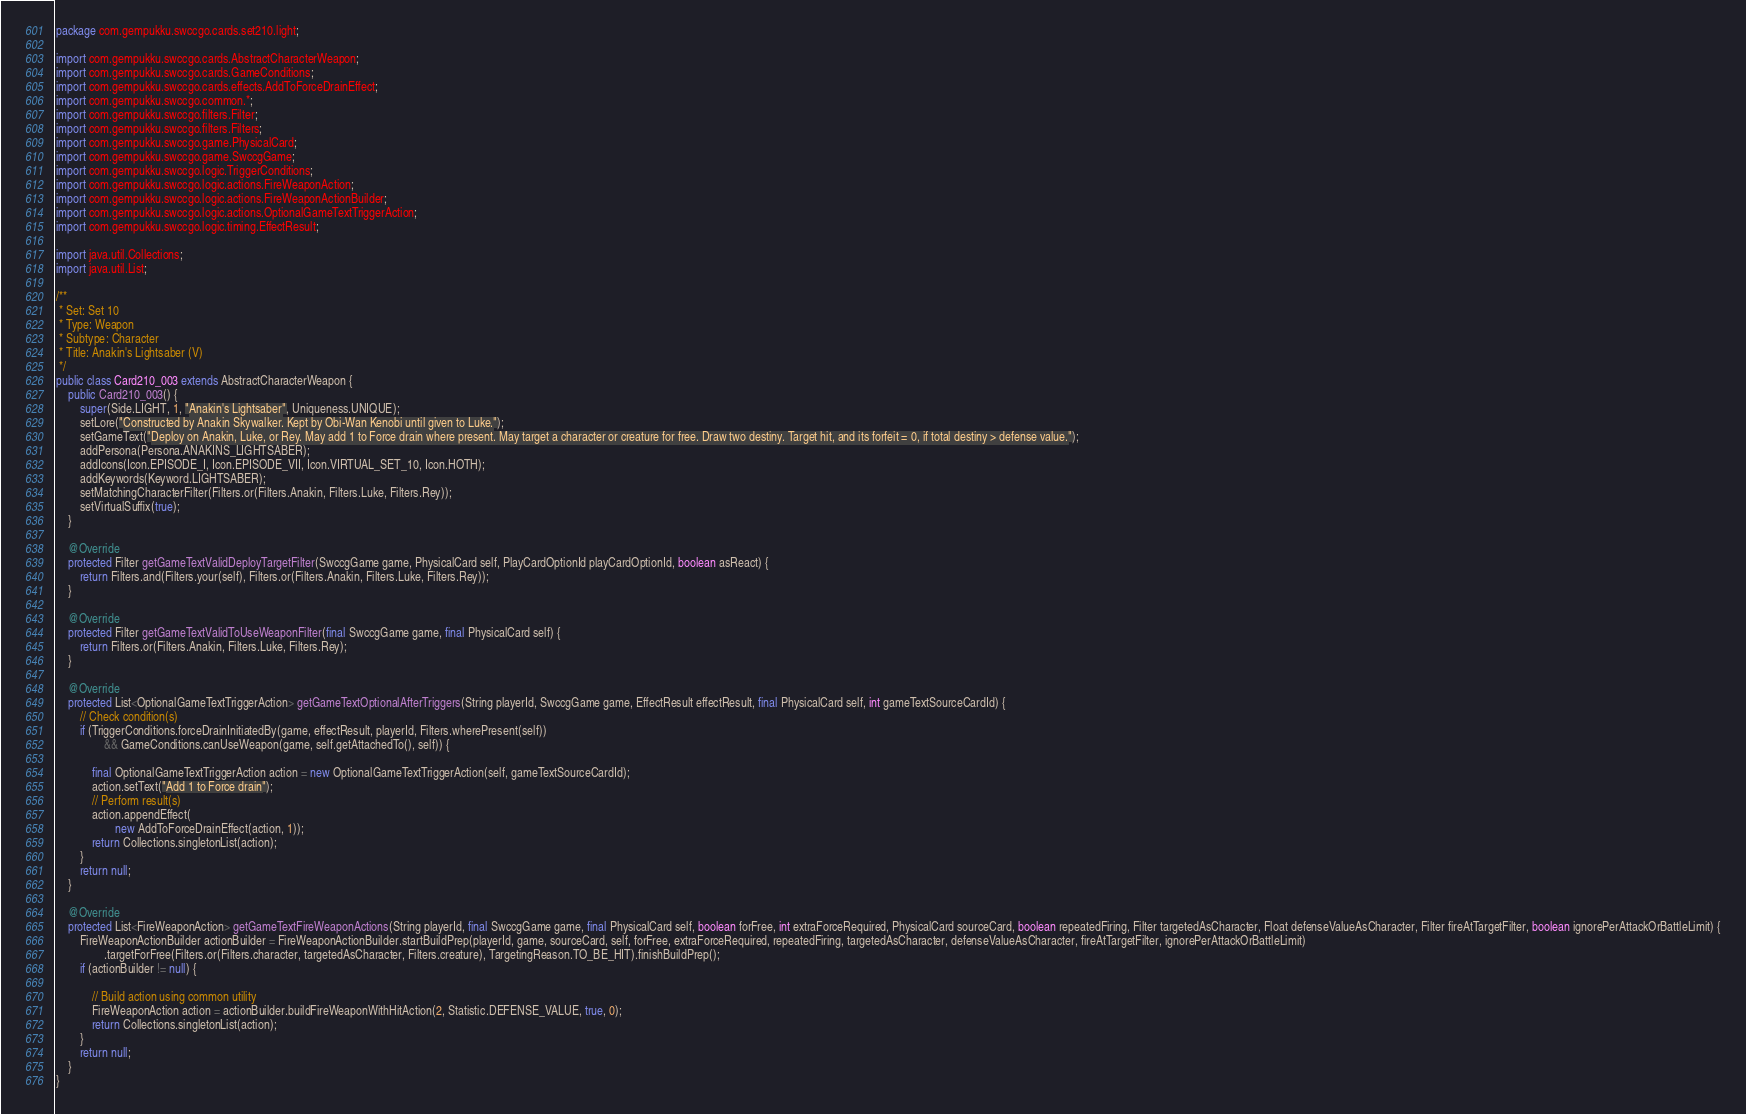Convert code to text. <code><loc_0><loc_0><loc_500><loc_500><_Java_>package com.gempukku.swccgo.cards.set210.light;

import com.gempukku.swccgo.cards.AbstractCharacterWeapon;
import com.gempukku.swccgo.cards.GameConditions;
import com.gempukku.swccgo.cards.effects.AddToForceDrainEffect;
import com.gempukku.swccgo.common.*;
import com.gempukku.swccgo.filters.Filter;
import com.gempukku.swccgo.filters.Filters;
import com.gempukku.swccgo.game.PhysicalCard;
import com.gempukku.swccgo.game.SwccgGame;
import com.gempukku.swccgo.logic.TriggerConditions;
import com.gempukku.swccgo.logic.actions.FireWeaponAction;
import com.gempukku.swccgo.logic.actions.FireWeaponActionBuilder;
import com.gempukku.swccgo.logic.actions.OptionalGameTextTriggerAction;
import com.gempukku.swccgo.logic.timing.EffectResult;

import java.util.Collections;
import java.util.List;

/**
 * Set: Set 10
 * Type: Weapon
 * Subtype: Character
 * Title: Anakin's Lightsaber (V)
 */
public class Card210_003 extends AbstractCharacterWeapon {
    public Card210_003() {
        super(Side.LIGHT, 1, "Anakin's Lightsaber", Uniqueness.UNIQUE);
        setLore("Constructed by Anakin Skywalker. Kept by Obi-Wan Kenobi until given to Luke.");
        setGameText("Deploy on Anakin, Luke, or Rey. May add 1 to Force drain where present. May target a character or creature for free. Draw two destiny. Target hit, and its forfeit = 0, if total destiny > defense value.");
        addPersona(Persona.ANAKINS_LIGHTSABER);
        addIcons(Icon.EPISODE_I, Icon.EPISODE_VII, Icon.VIRTUAL_SET_10, Icon.HOTH);
        addKeywords(Keyword.LIGHTSABER);
        setMatchingCharacterFilter(Filters.or(Filters.Anakin, Filters.Luke, Filters.Rey));
        setVirtualSuffix(true);
    }

    @Override
    protected Filter getGameTextValidDeployTargetFilter(SwccgGame game, PhysicalCard self, PlayCardOptionId playCardOptionId, boolean asReact) {
        return Filters.and(Filters.your(self), Filters.or(Filters.Anakin, Filters.Luke, Filters.Rey));
    }

    @Override
    protected Filter getGameTextValidToUseWeaponFilter(final SwccgGame game, final PhysicalCard self) {
        return Filters.or(Filters.Anakin, Filters.Luke, Filters.Rey);
    }

    @Override
    protected List<OptionalGameTextTriggerAction> getGameTextOptionalAfterTriggers(String playerId, SwccgGame game, EffectResult effectResult, final PhysicalCard self, int gameTextSourceCardId) {
        // Check condition(s)
        if (TriggerConditions.forceDrainInitiatedBy(game, effectResult, playerId, Filters.wherePresent(self))
                && GameConditions.canUseWeapon(game, self.getAttachedTo(), self)) {

            final OptionalGameTextTriggerAction action = new OptionalGameTextTriggerAction(self, gameTextSourceCardId);
            action.setText("Add 1 to Force drain");
            // Perform result(s)
            action.appendEffect(
                    new AddToForceDrainEffect(action, 1));
            return Collections.singletonList(action);
        }
        return null;
    }

    @Override
    protected List<FireWeaponAction> getGameTextFireWeaponActions(String playerId, final SwccgGame game, final PhysicalCard self, boolean forFree, int extraForceRequired, PhysicalCard sourceCard, boolean repeatedFiring, Filter targetedAsCharacter, Float defenseValueAsCharacter, Filter fireAtTargetFilter, boolean ignorePerAttackOrBattleLimit) {
        FireWeaponActionBuilder actionBuilder = FireWeaponActionBuilder.startBuildPrep(playerId, game, sourceCard, self, forFree, extraForceRequired, repeatedFiring, targetedAsCharacter, defenseValueAsCharacter, fireAtTargetFilter, ignorePerAttackOrBattleLimit)
                .targetForFree(Filters.or(Filters.character, targetedAsCharacter, Filters.creature), TargetingReason.TO_BE_HIT).finishBuildPrep();
        if (actionBuilder != null) {

            // Build action using common utility
            FireWeaponAction action = actionBuilder.buildFireWeaponWithHitAction(2, Statistic.DEFENSE_VALUE, true, 0);
            return Collections.singletonList(action);
        }
        return null;
    }
}
</code> 